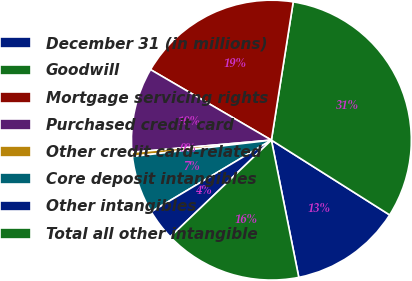Convert chart. <chart><loc_0><loc_0><loc_500><loc_500><pie_chart><fcel>December 31 (in millions)<fcel>Goodwill<fcel>Mortgage servicing rights<fcel>Purchased credit card<fcel>Other credit card-related<fcel>Core deposit intangibles<fcel>Other intangibles<fcel>Total all other intangible<nl><fcel>12.89%<fcel>31.49%<fcel>19.09%<fcel>9.79%<fcel>0.49%<fcel>6.69%<fcel>3.59%<fcel>15.99%<nl></chart> 